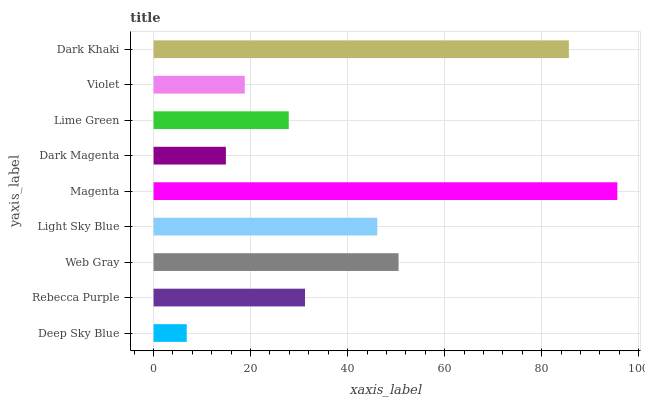Is Deep Sky Blue the minimum?
Answer yes or no. Yes. Is Magenta the maximum?
Answer yes or no. Yes. Is Rebecca Purple the minimum?
Answer yes or no. No. Is Rebecca Purple the maximum?
Answer yes or no. No. Is Rebecca Purple greater than Deep Sky Blue?
Answer yes or no. Yes. Is Deep Sky Blue less than Rebecca Purple?
Answer yes or no. Yes. Is Deep Sky Blue greater than Rebecca Purple?
Answer yes or no. No. Is Rebecca Purple less than Deep Sky Blue?
Answer yes or no. No. Is Rebecca Purple the high median?
Answer yes or no. Yes. Is Rebecca Purple the low median?
Answer yes or no. Yes. Is Dark Khaki the high median?
Answer yes or no. No. Is Magenta the low median?
Answer yes or no. No. 